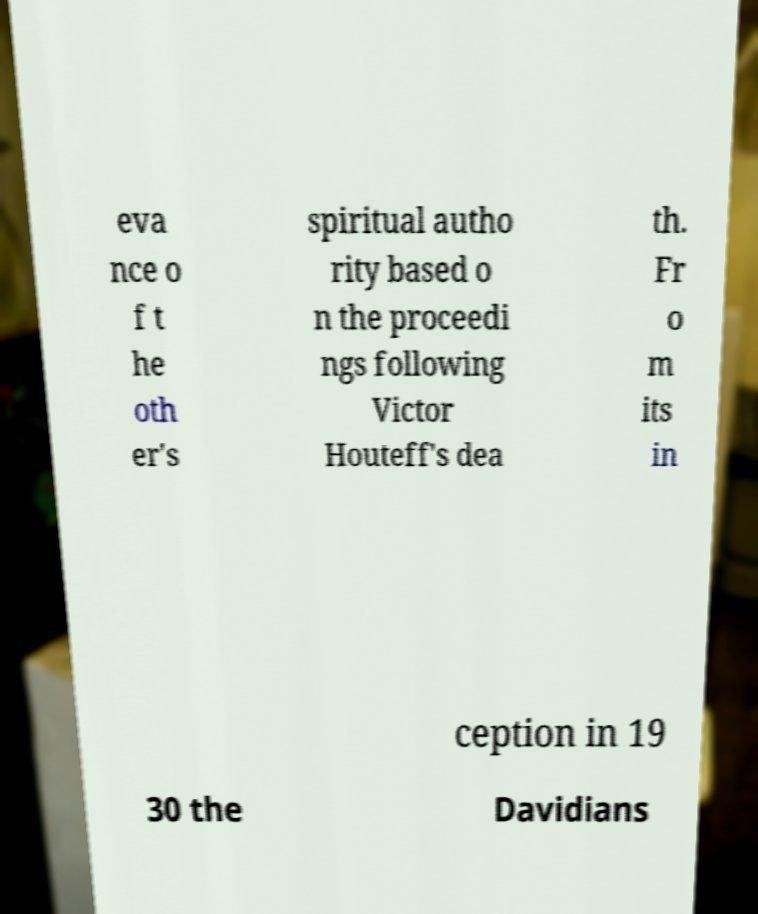Please identify and transcribe the text found in this image. eva nce o f t he oth er's spiritual autho rity based o n the proceedi ngs following Victor Houteff's dea th. Fr o m its in ception in 19 30 the Davidians 